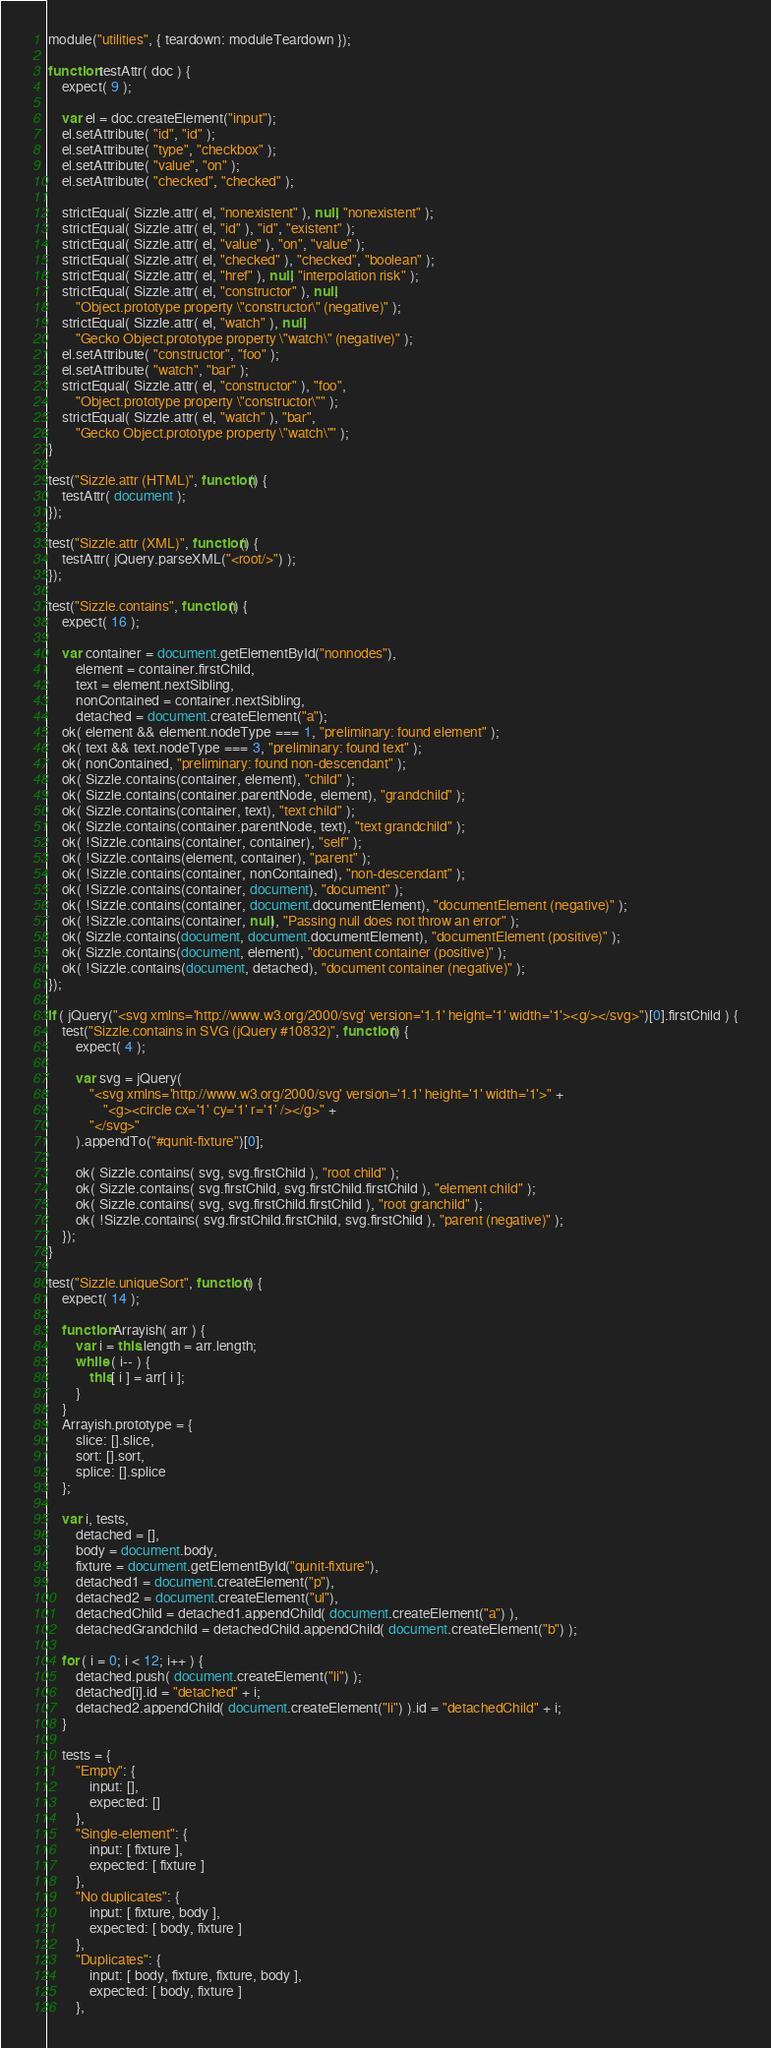<code> <loc_0><loc_0><loc_500><loc_500><_JavaScript_>module("utilities", { teardown: moduleTeardown });

function testAttr( doc ) {
	expect( 9 );

	var el = doc.createElement("input");
	el.setAttribute( "id", "id" );
	el.setAttribute( "type", "checkbox" );
	el.setAttribute( "value", "on" );
	el.setAttribute( "checked", "checked" );

	strictEqual( Sizzle.attr( el, "nonexistent" ), null, "nonexistent" );
	strictEqual( Sizzle.attr( el, "id" ), "id", "existent" );
	strictEqual( Sizzle.attr( el, "value" ), "on", "value" );
	strictEqual( Sizzle.attr( el, "checked" ), "checked", "boolean" );
	strictEqual( Sizzle.attr( el, "href" ), null, "interpolation risk" );
	strictEqual( Sizzle.attr( el, "constructor" ), null,
		"Object.prototype property \"constructor\" (negative)" );
	strictEqual( Sizzle.attr( el, "watch" ), null,
		"Gecko Object.prototype property \"watch\" (negative)" );
	el.setAttribute( "constructor", "foo" );
	el.setAttribute( "watch", "bar" );
	strictEqual( Sizzle.attr( el, "constructor" ), "foo",
		"Object.prototype property \"constructor\"" );
	strictEqual( Sizzle.attr( el, "watch" ), "bar",
		"Gecko Object.prototype property \"watch\"" );
}

test("Sizzle.attr (HTML)", function() {
	testAttr( document );
});

test("Sizzle.attr (XML)", function() {
	testAttr( jQuery.parseXML("<root/>") );
});

test("Sizzle.contains", function() {
	expect( 16 );

	var container = document.getElementById("nonnodes"),
		element = container.firstChild,
		text = element.nextSibling,
		nonContained = container.nextSibling,
		detached = document.createElement("a");
	ok( element && element.nodeType === 1, "preliminary: found element" );
	ok( text && text.nodeType === 3, "preliminary: found text" );
	ok( nonContained, "preliminary: found non-descendant" );
	ok( Sizzle.contains(container, element), "child" );
	ok( Sizzle.contains(container.parentNode, element), "grandchild" );
	ok( Sizzle.contains(container, text), "text child" );
	ok( Sizzle.contains(container.parentNode, text), "text grandchild" );
	ok( !Sizzle.contains(container, container), "self" );
	ok( !Sizzle.contains(element, container), "parent" );
	ok( !Sizzle.contains(container, nonContained), "non-descendant" );
	ok( !Sizzle.contains(container, document), "document" );
	ok( !Sizzle.contains(container, document.documentElement), "documentElement (negative)" );
	ok( !Sizzle.contains(container, null), "Passing null does not throw an error" );
	ok( Sizzle.contains(document, document.documentElement), "documentElement (positive)" );
	ok( Sizzle.contains(document, element), "document container (positive)" );
	ok( !Sizzle.contains(document, detached), "document container (negative)" );
});

if ( jQuery("<svg xmlns='http://www.w3.org/2000/svg' version='1.1' height='1' width='1'><g/></svg>")[0].firstChild ) {
	test("Sizzle.contains in SVG (jQuery #10832)", function() {
		expect( 4 );

		var svg = jQuery(
			"<svg xmlns='http://www.w3.org/2000/svg' version='1.1' height='1' width='1'>" +
				"<g><circle cx='1' cy='1' r='1' /></g>" +
			"</svg>"
		).appendTo("#qunit-fixture")[0];

		ok( Sizzle.contains( svg, svg.firstChild ), "root child" );
		ok( Sizzle.contains( svg.firstChild, svg.firstChild.firstChild ), "element child" );
		ok( Sizzle.contains( svg, svg.firstChild.firstChild ), "root granchild" );
		ok( !Sizzle.contains( svg.firstChild.firstChild, svg.firstChild ), "parent (negative)" );
	});
}

test("Sizzle.uniqueSort", function() {
	expect( 14 );

	function Arrayish( arr ) {
		var i = this.length = arr.length;
		while ( i-- ) {
			this[ i ] = arr[ i ];
		}
	}
	Arrayish.prototype = {
		slice: [].slice,
		sort: [].sort,
		splice: [].splice
	};

	var i, tests,
		detached = [],
		body = document.body,
		fixture = document.getElementById("qunit-fixture"),
		detached1 = document.createElement("p"),
		detached2 = document.createElement("ul"),
		detachedChild = detached1.appendChild( document.createElement("a") ),
		detachedGrandchild = detachedChild.appendChild( document.createElement("b") );

	for ( i = 0; i < 12; i++ ) {
		detached.push( document.createElement("li") );
		detached[i].id = "detached" + i;
		detached2.appendChild( document.createElement("li") ).id = "detachedChild" + i;
	}

	tests = {
		"Empty": {
			input: [],
			expected: []
		},
		"Single-element": {
			input: [ fixture ],
			expected: [ fixture ]
		},
		"No duplicates": {
			input: [ fixture, body ],
			expected: [ body, fixture ]
		},
		"Duplicates": {
			input: [ body, fixture, fixture, body ],
			expected: [ body, fixture ]
		},</code> 